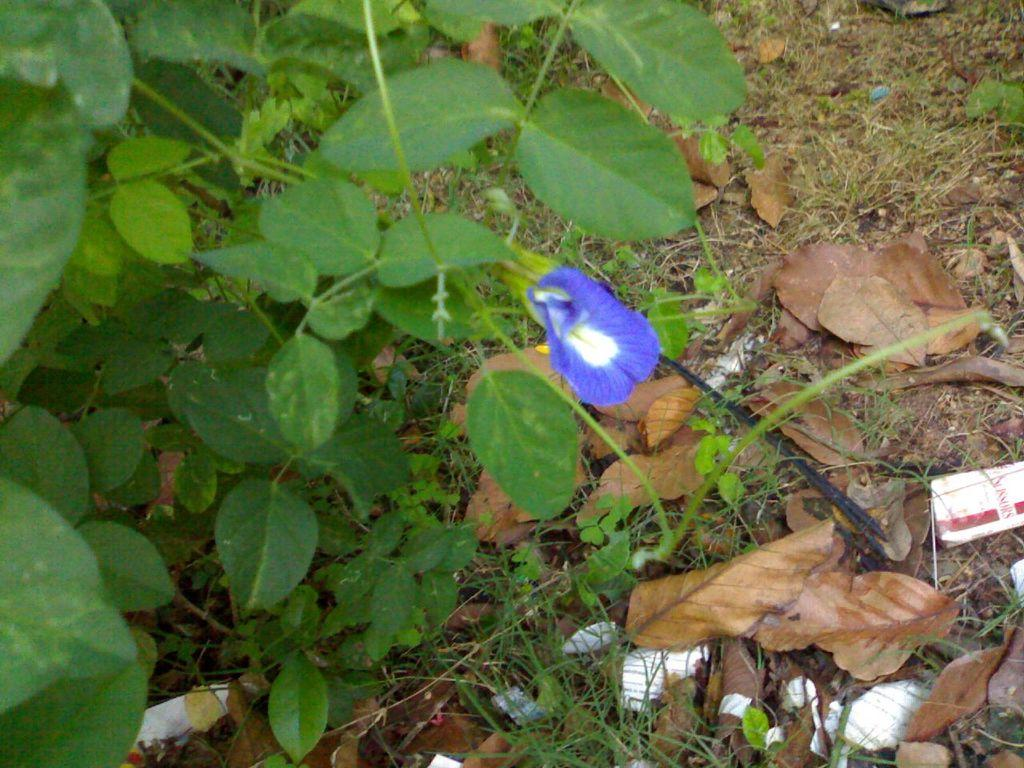What type of living organisms can be seen in the image? Plants can be seen in the image. What color are the flowers on the plants? The flowers on the plants have a brinjal-colored flower. What can be found at the bottom of the image? There are dry leaves at the bottom of the image. What type of skin condition can be seen on the plants in the image? There is no mention of any skin condition on the plants in the image. The plants have brinjal-colored flowers, but their skin condition is not discussed. 